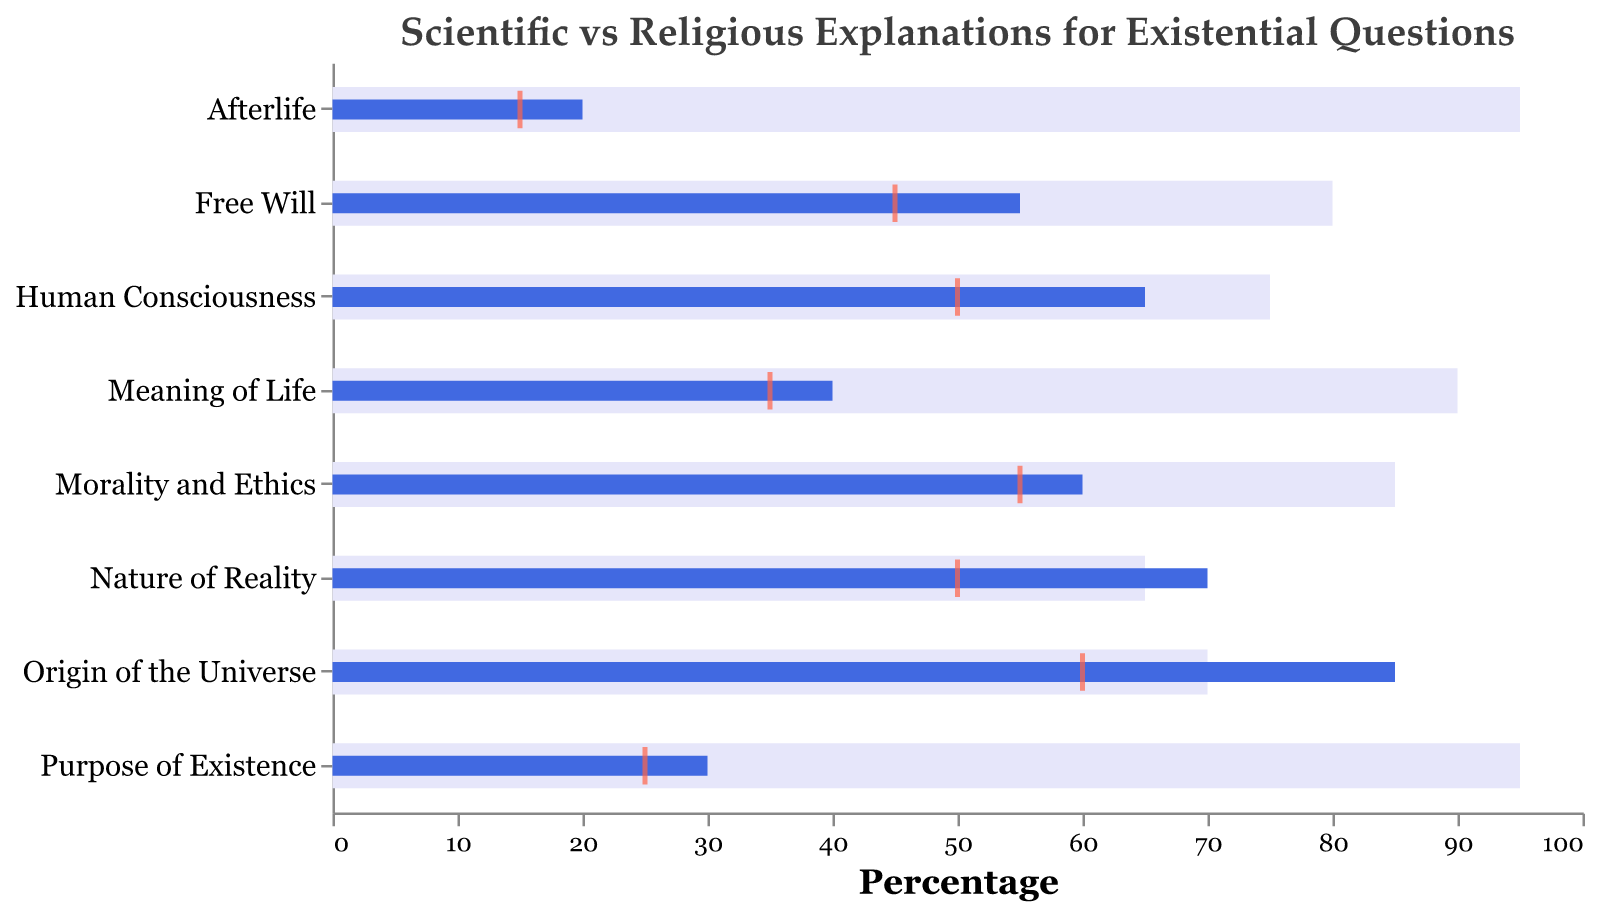What is the title of the figure? The title is usually displayed at the top of the chart and provides a brief description of what the figure represents.
Answer: Scientific vs Religious Explanations for Existential Questions What percentage represents the scientific explanation for the origin of the universe? Look at the bar corresponding to the "Origin of the Universe" category and find the length of the blue bar representing the scientific explanation.
Answer: 85 In terms of the overlap, which existential question shows the least agreement between scientific and religious explanations? Identify the tick marks representing overlap for each category and locate the one with the smallest value.
Answer: Afterlife Which category has the highest religious explanation value? Compare the lengths of the light purple bars for each category and identify the longest one.
Answer: Afterlife and Purpose of Existence (both at 95) Calculate the average scientific explanation value for all categories. Sum the scientific explanation values for all categories and divide by the number of categories: (85 + 40 + 65 + 60 + 20 + 55 + 30 + 70) / 8.
Answer: 53.1 Which category shows the largest difference between scientific and religious explanations? Subtract the scientific explanation value from the religious explanation value for each category and identify the largest difference.
Answer: Afterlife Which existential question has the most similar values for scientific and religious explanations? Compare the differences between the scientific and religious explanations in each category and find the smallest difference.
Answer: Nature of Reality What is the median value for the overlap in the data? Sort the overlap values in ascending order (15, 25, 35, 45, 50, 50, 55, 60) and find the middle value(s). Since there are 8 values, the median is the average of the 4th and 5th values: (45 + 50) / 2.
Answer: 47.5 For which categories are the scientific and religious explanations both more than 50%? Check the values for both explanations in each category and identify those where both are greater than 50.
Answer: Origin of the Universe, Human Consciousness, Morality and Ethics, Free Will, Nature of Reality 